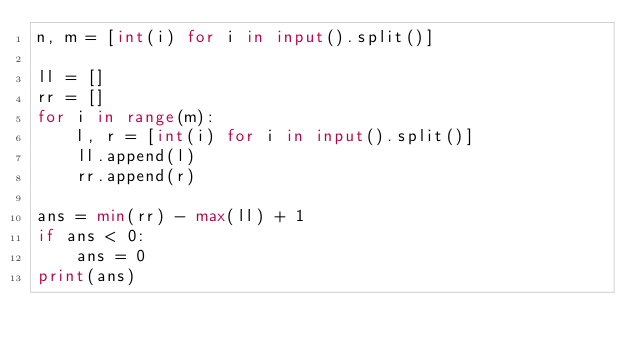Convert code to text. <code><loc_0><loc_0><loc_500><loc_500><_Python_>n, m = [int(i) for i in input().split()]

ll = []
rr = []
for i in range(m):
    l, r = [int(i) for i in input().split()]
    ll.append(l)
    rr.append(r)

ans = min(rr) - max(ll) + 1
if ans < 0:
    ans = 0
print(ans)</code> 